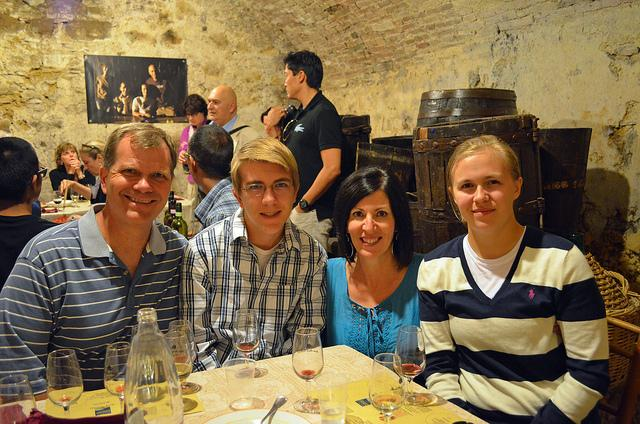What pattern is the young guy's shirt? plaid 